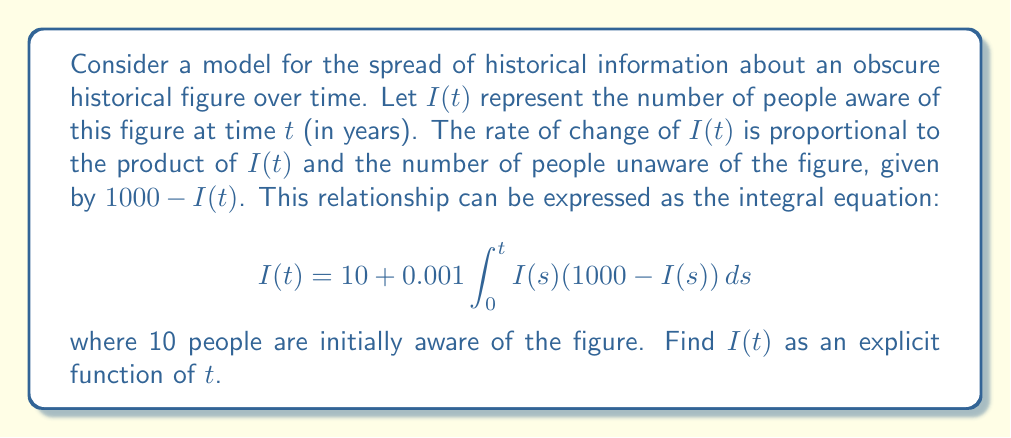Provide a solution to this math problem. To solve this integral equation, we'll follow these steps:

1) First, we recognize this as a Volterra integral equation of the second kind.

2) We can differentiate both sides with respect to $t$ to convert it into a differential equation:

   $$\frac{dI}{dt} = 0.001 I(t)(1000 - I(t))$$

3) This is a separable differential equation. We can rewrite it as:

   $$\frac{dI}{I(1000 - I)} = 0.001 dt$$

4) Integrate both sides:

   $$\int \frac{dI}{I(1000 - I)} = 0.001 \int dt$$

5) The left side can be integrated using partial fractions:

   $$\int \frac{dI}{I(1000 - I)} = \frac{1}{1000} \int (\frac{1}{I} + \frac{1}{1000-I}) dI = \frac{1}{1000}[\ln|I| - \ln|1000-I|] + C$$

6) After integration, we have:

   $$\frac{1}{1000}[\ln|I| - \ln|1000-I|] = 0.001t + C$$

7) Simplify and solve for $I$:

   $$\ln|\frac{I}{1000-I}| = t + C'$$

   $$\frac{I}{1000-I} = Ke^t$$ (where $K = e^{C'}$)

   $$I = \frac{1000Ke^t}{1+Ke^t}$$

8) Use the initial condition $I(0) = 10$ to find $K$:

   $$10 = \frac{1000K}{1+K}$$
   $$K = \frac{1}{99}$$

9) Therefore, the final solution is:

   $$I(t) = \frac{1000\frac{1}{99}e^t}{1+\frac{1}{99}e^t} = \frac{1000e^t}{99+e^t}$$
Answer: $I(t) = \frac{1000e^t}{99+e^t}$ 